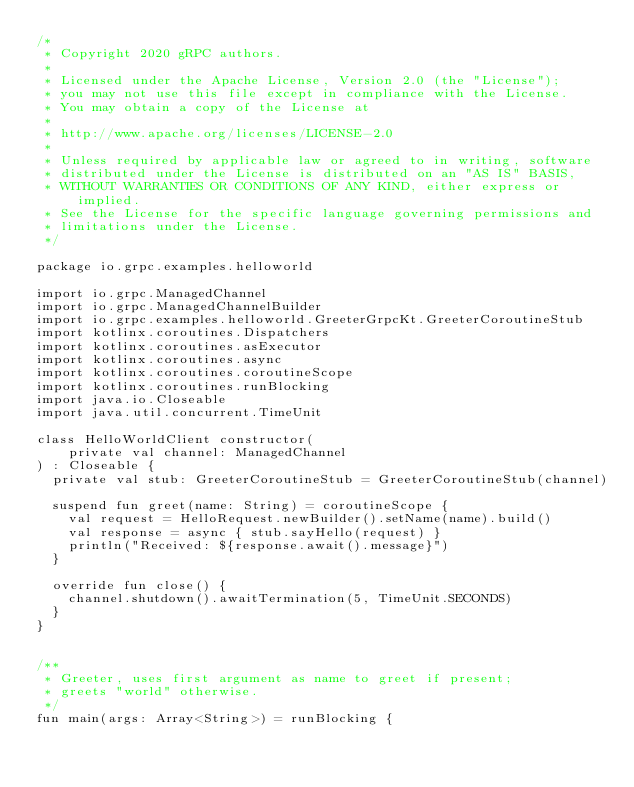Convert code to text. <code><loc_0><loc_0><loc_500><loc_500><_Kotlin_>/*
 * Copyright 2020 gRPC authors.
 *
 * Licensed under the Apache License, Version 2.0 (the "License");
 * you may not use this file except in compliance with the License.
 * You may obtain a copy of the License at
 *
 * http://www.apache.org/licenses/LICENSE-2.0
 *
 * Unless required by applicable law or agreed to in writing, software
 * distributed under the License is distributed on an "AS IS" BASIS,
 * WITHOUT WARRANTIES OR CONDITIONS OF ANY KIND, either express or implied.
 * See the License for the specific language governing permissions and
 * limitations under the License.
 */

package io.grpc.examples.helloworld

import io.grpc.ManagedChannel
import io.grpc.ManagedChannelBuilder
import io.grpc.examples.helloworld.GreeterGrpcKt.GreeterCoroutineStub
import kotlinx.coroutines.Dispatchers
import kotlinx.coroutines.asExecutor
import kotlinx.coroutines.async
import kotlinx.coroutines.coroutineScope
import kotlinx.coroutines.runBlocking
import java.io.Closeable
import java.util.concurrent.TimeUnit

class HelloWorldClient constructor(
    private val channel: ManagedChannel
) : Closeable {
  private val stub: GreeterCoroutineStub = GreeterCoroutineStub(channel)

  suspend fun greet(name: String) = coroutineScope {
    val request = HelloRequest.newBuilder().setName(name).build()
    val response = async { stub.sayHello(request) }
    println("Received: ${response.await().message}")
  }

  override fun close() {
    channel.shutdown().awaitTermination(5, TimeUnit.SECONDS)
  }
}


/**
 * Greeter, uses first argument as name to greet if present;
 * greets "world" otherwise.
 */
fun main(args: Array<String>) = runBlocking {</code> 